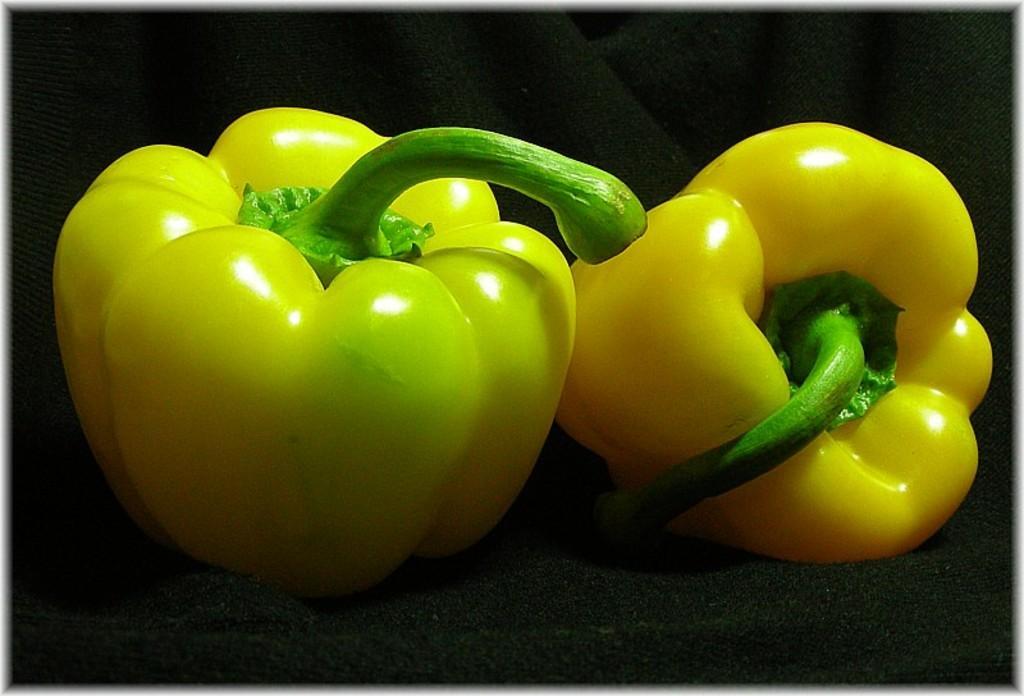Can you describe this image briefly? In this image I can see the capsicum which are in yellow and green color. These are on the black color surface. 